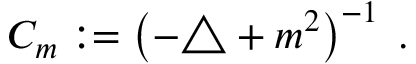<formula> <loc_0><loc_0><loc_500><loc_500>C _ { m } \colon = \left ( - \triangle + m ^ { 2 } \right ) ^ { - 1 } \, .</formula> 